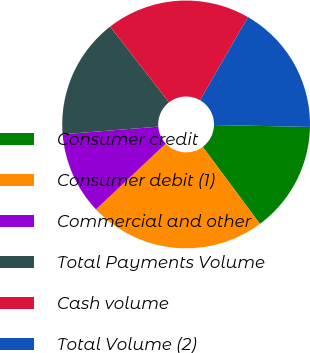Convert chart. <chart><loc_0><loc_0><loc_500><loc_500><pie_chart><fcel>Consumer credit<fcel>Consumer debit (1)<fcel>Commercial and other<fcel>Total Payments Volume<fcel>Cash volume<fcel>Total Volume (2)<nl><fcel>14.52%<fcel>23.13%<fcel>10.76%<fcel>15.76%<fcel>18.83%<fcel>17.0%<nl></chart> 